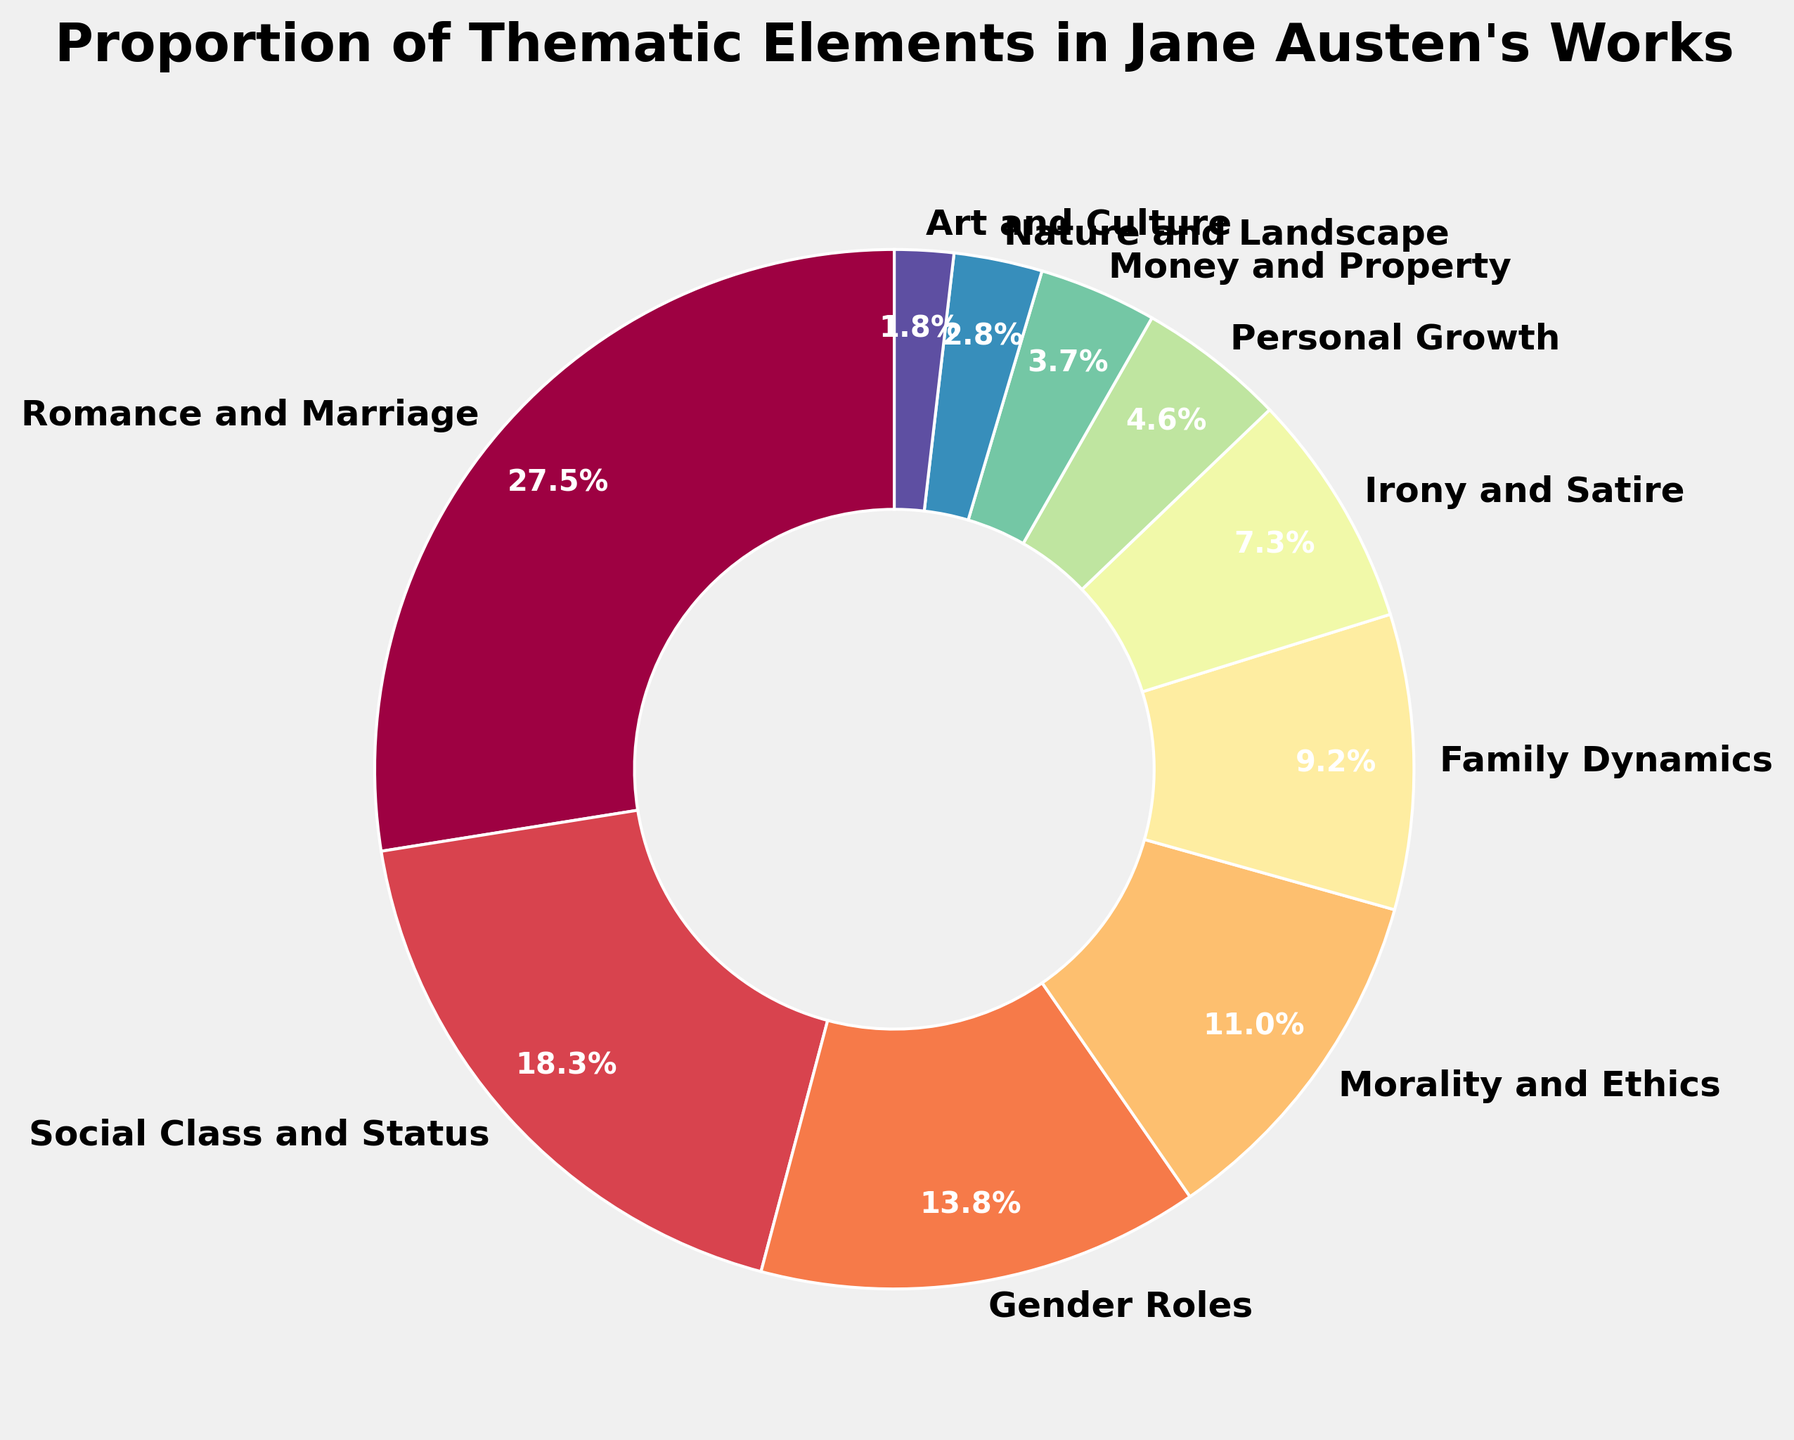What thematic element occupies the largest portion of the pie chart? The segment representing "Romance and Marriage" occupies the largest portion, indicated by the largest percentage value given as 30%.
Answer: Romance and Marriage How much larger is the "Social Class and Status" segment than the "Gender Roles" segment? The "Social Class and Status" segment is 20%, and the "Gender Roles" segment is 15%. The difference is calculated as 20% - 15% = 5%.
Answer: 5% What is the combined percentage of the three smallest thematic elements? The three smallest thematic elements are "Nature and Landscape" (3%), "Art and Culture" (2%), and "Money and Property" (4%). The combined percentage is 3% + 2% + 4% = 9%.
Answer: 9% Which thematic segment is represented in bright red, and what is its percentage? The visual information from the pie colors indicates a bright red segment. On checking the segments, "Romance and Marriage" stands out with 30%. Hence, the bright red segment is "Romance and Marriage."
Answer: Romance and Marriage Are "Gender Roles" and "Irony and Satire" almost equally represented? Checking the values, "Gender Roles" is 15% and "Irony and Satire" is 8%. Comparing 15% to 8% shows that they aren’t almost equal as 15% is nearly double 8%.
Answer: No How do the percentages of "Family Dynamics" and "Personal Growth" compare? The value for "Family Dynamics" is 10%, and "Personal Growth" is 5%. Comparing the two, "Family Dynamics" is twice the percentage of "Personal Growth."
Answer: Family Dynamics is twice Personal Growth What percentage of thematic elements is devoted to social issues, combining "Social Class and Status" and "Gender Roles"? "Social Class and Status" is given as 20%, and "Gender Roles" is 15%. Summing them up gives 20% + 15% = 35%.
Answer: 35% Of all thematic elements, which one is closest to 10%? Among the given percentages, "Family Dynamics" is exactly 10%.
Answer: Family Dynamics Calculate the total percentage contributed by elements related to human relationships ("Romance and Marriage", "Family Dynamics", "Personal Growth"). The relevant percentages are "Romance and Marriage" (30%), "Family Dynamics" (10%), and "Personal Growth" (5%). Adding these gives 30% + 10% + 5% = 45%.
Answer: 45% Which two thematic elements together sum up to more than one-third of the pie chart? Looking at the data, "Romance and Marriage" is 30%, and "Social Class and Status" is 20%. Together these add up to 30% + 20% = 50%, which is more than one-third (33.33%).
Answer: Romance and Marriage and Social Class and Status 